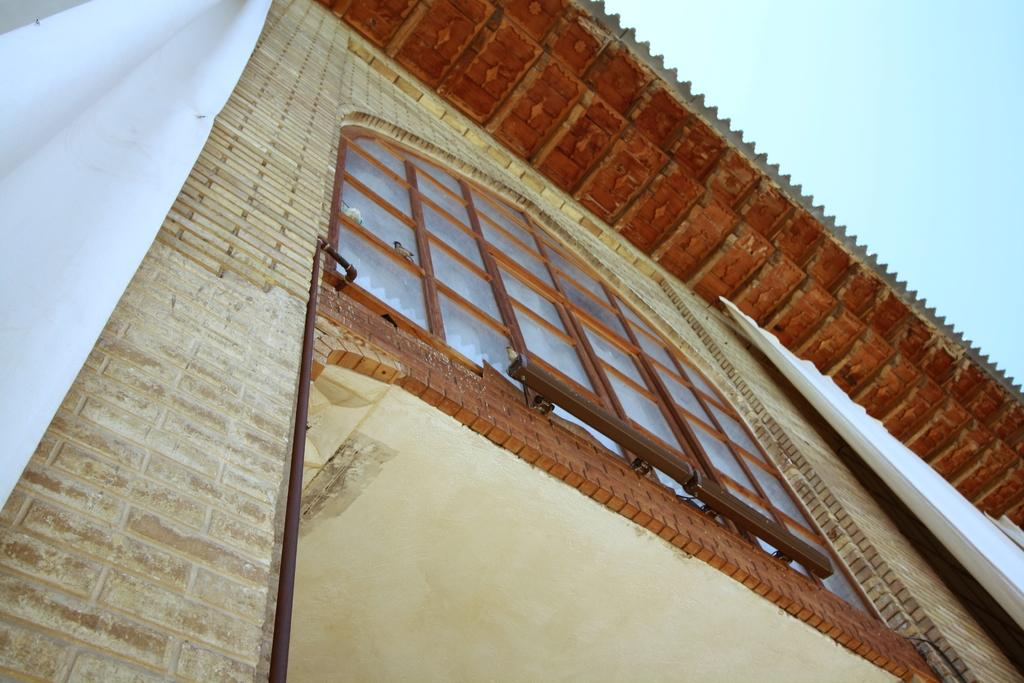What is the main subject of the image? The main subject of the image is a house. Where is the house located in the image? The house is in the center of the image. What feature can be seen on the house? The house has a window. Are there any other objects or elements in the image related to the house? Yes, there are curtains in the image. What type of soap is being used to clean the rings in the image? There are no rings or soap present in the image; it only features a house with a window and curtains. 